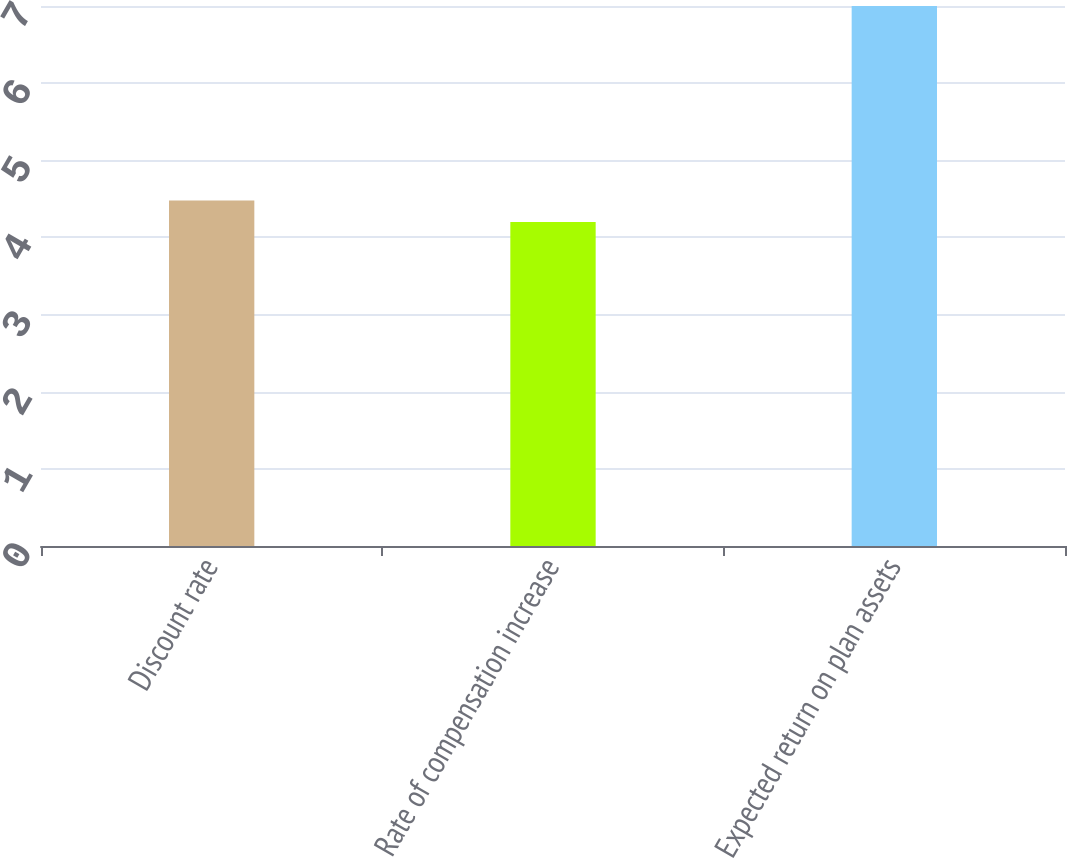Convert chart to OTSL. <chart><loc_0><loc_0><loc_500><loc_500><bar_chart><fcel>Discount rate<fcel>Rate of compensation increase<fcel>Expected return on plan assets<nl><fcel>4.48<fcel>4.2<fcel>7<nl></chart> 